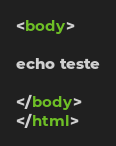<code> <loc_0><loc_0><loc_500><loc_500><_HTML_>
<body>

echo teste

</body>
</html>
</code> 